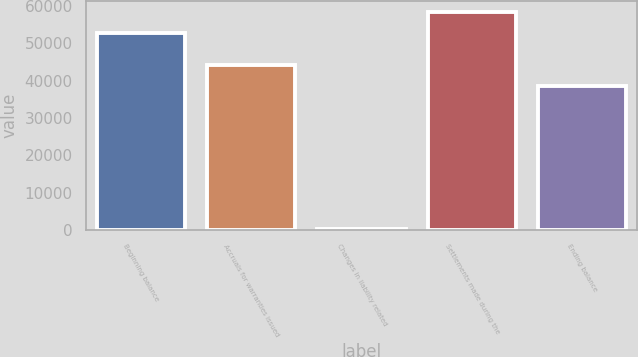<chart> <loc_0><loc_0><loc_500><loc_500><bar_chart><fcel>Beginning balance<fcel>Accruals for warranties issued<fcel>Changes in liability related<fcel>Settlements made during the<fcel>Ending balance<nl><fcel>52838<fcel>44261.4<fcel>254<fcel>58399.4<fcel>38700<nl></chart> 